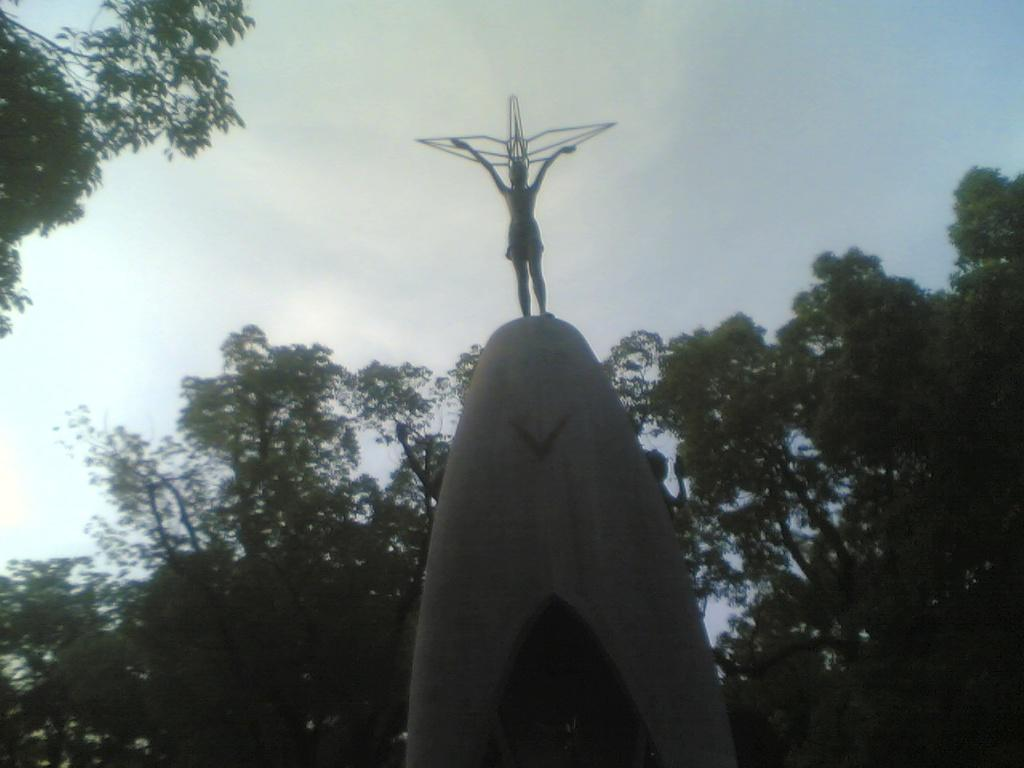What can be seen in the background of the image? The sky is visible in the image. What type of vegetation is present in the image? There are trees in the image. What is the statue on in the image? The statue is on a pedestal in the image. How many screws are visible on the statue in the image? There are no screws visible on the statue in the image. Can you see a baby playing near the trees in the image? There is no baby present in the image; it only features the sky, trees, and the statue on a pedestal. 